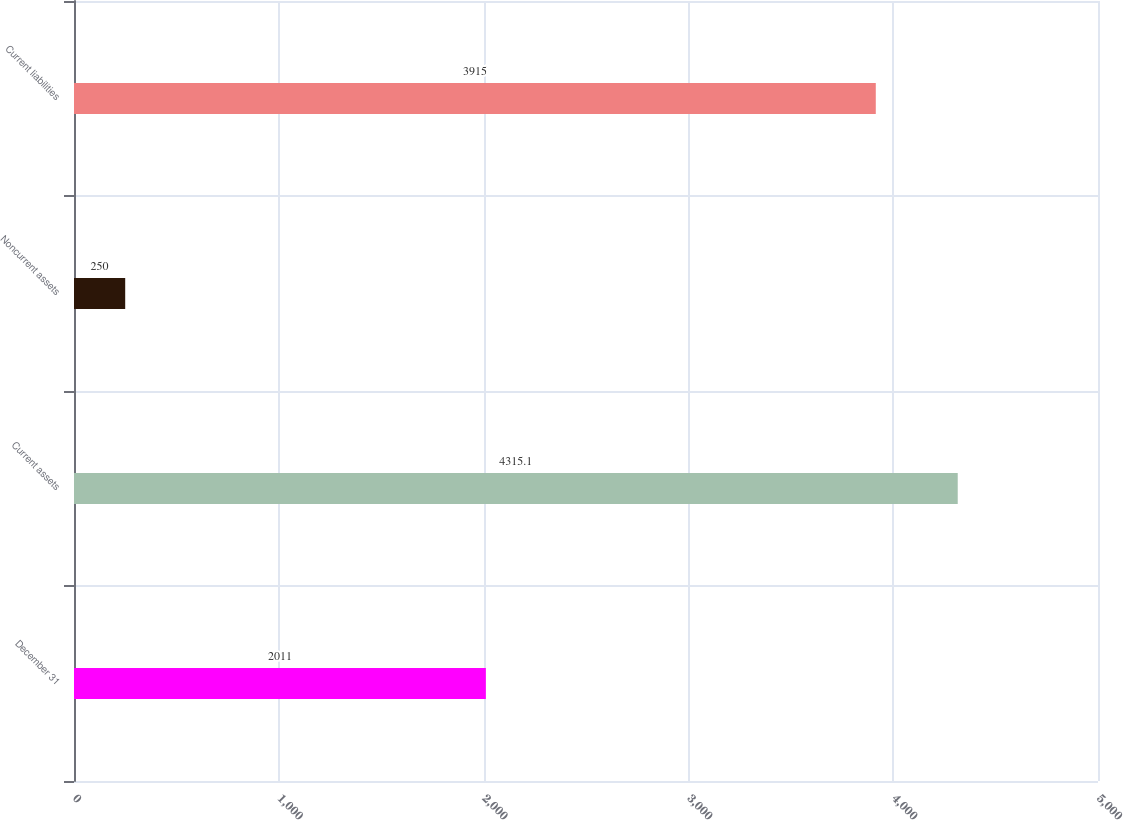<chart> <loc_0><loc_0><loc_500><loc_500><bar_chart><fcel>December 31<fcel>Current assets<fcel>Noncurrent assets<fcel>Current liabilities<nl><fcel>2011<fcel>4315.1<fcel>250<fcel>3915<nl></chart> 